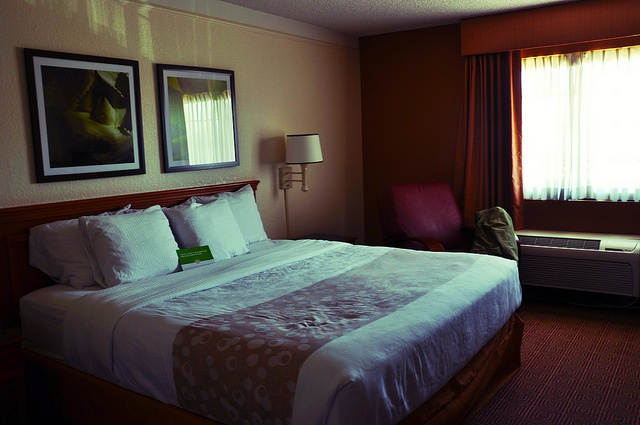Describe the objects in this image and their specific colors. I can see bed in black, gray, and lightblue tones and chair in black, maroon, and gray tones in this image. 